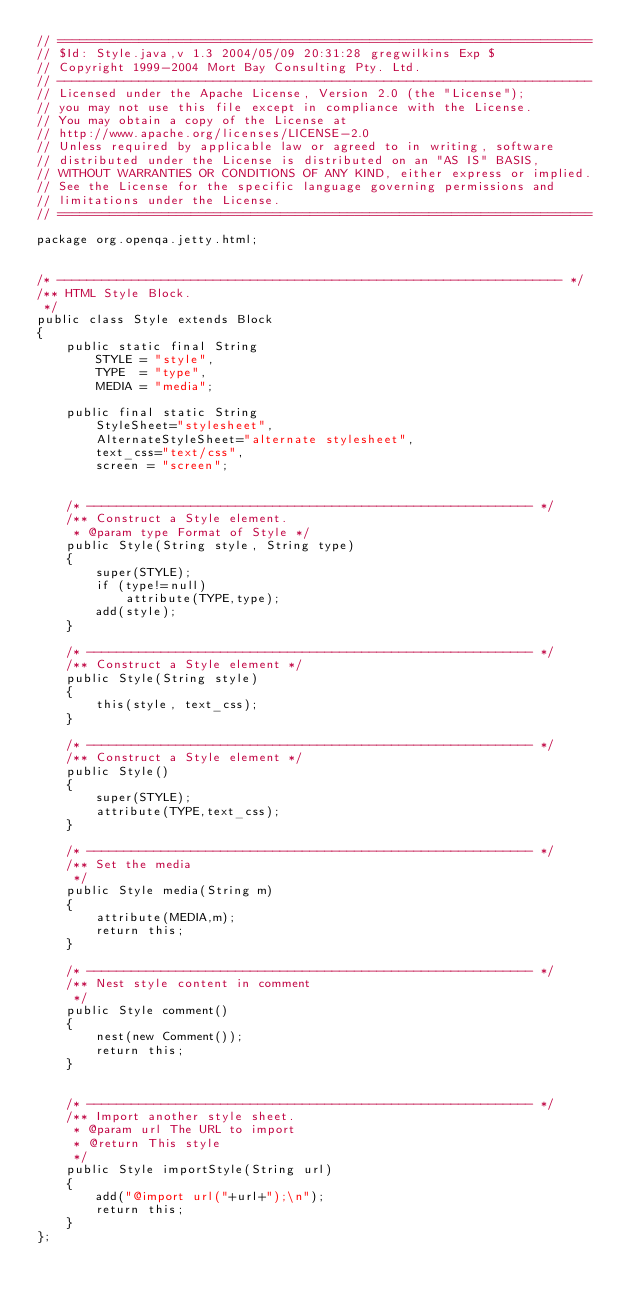Convert code to text. <code><loc_0><loc_0><loc_500><loc_500><_Java_>// ========================================================================
// $Id: Style.java,v 1.3 2004/05/09 20:31:28 gregwilkins Exp $
// Copyright 1999-2004 Mort Bay Consulting Pty. Ltd.
// ------------------------------------------------------------------------
// Licensed under the Apache License, Version 2.0 (the "License");
// you may not use this file except in compliance with the License.
// You may obtain a copy of the License at 
// http://www.apache.org/licenses/LICENSE-2.0
// Unless required by applicable law or agreed to in writing, software
// distributed under the License is distributed on an "AS IS" BASIS,
// WITHOUT WARRANTIES OR CONDITIONS OF ANY KIND, either express or implied.
// See the License for the specific language governing permissions and
// limitations under the License.
// ========================================================================

package org.openqa.jetty.html;


/* -------------------------------------------------------------------- */
/** HTML Style Block.
 */
public class Style extends Block
{
    public static final String
        STYLE = "style",
        TYPE  = "type",
        MEDIA = "media";
    
    public final static String
        StyleSheet="stylesheet",
        AlternateStyleSheet="alternate stylesheet",
        text_css="text/css",
        screen = "screen";

    
    /* ------------------------------------------------------------ */
    /** Construct a Style element.
     * @param type Format of Style */
    public Style(String style, String type)
    {
        super(STYLE);
        if (type!=null)
            attribute(TYPE,type);
        add(style);
    }

    /* ------------------------------------------------------------ */
    /** Construct a Style element */
    public Style(String style)
    {
        this(style, text_css);
    }
    
    /* ------------------------------------------------------------ */
    /** Construct a Style element */
    public Style()
    {
        super(STYLE);
        attribute(TYPE,text_css);
    }
    
    /* ------------------------------------------------------------ */
    /** Set the media
     */
    public Style media(String m)
    {
        attribute(MEDIA,m);
        return this;
    }
    
    /* ------------------------------------------------------------ */
    /** Nest style content in comment 
     */
    public Style comment()
    {
        nest(new Comment());
        return this;
    }


    /* ------------------------------------------------------------ */
    /** Import another style sheet.
     * @param url The URL to import
     * @return This style
     */
    public Style importStyle(String url)
    {
        add("@import url("+url+");\n");
        return this;
    }
};




</code> 